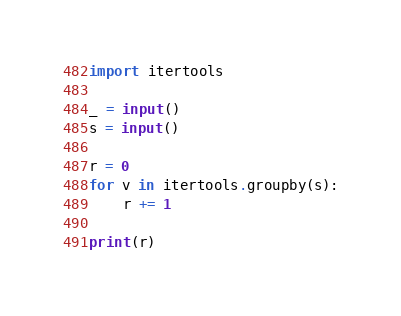Convert code to text. <code><loc_0><loc_0><loc_500><loc_500><_Python_>import itertools

_ = input()
s = input()

r = 0
for v in itertools.groupby(s):
    r += 1

print(r)
</code> 